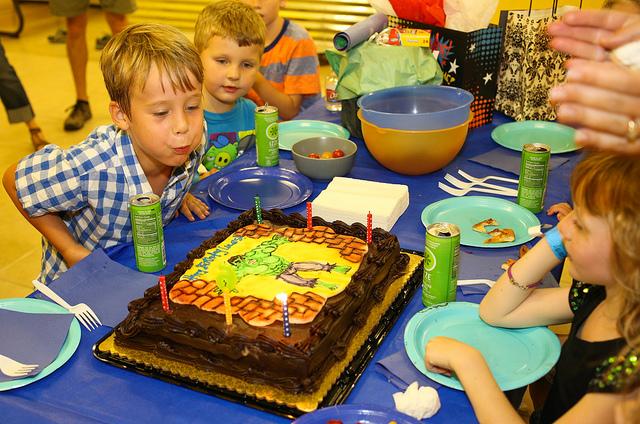What character is pictured on the cake?
Keep it brief. Hulk. What color is the tablecloth?
Short answer required. Blue. What occasion is this?
Keep it brief. Birthday. 